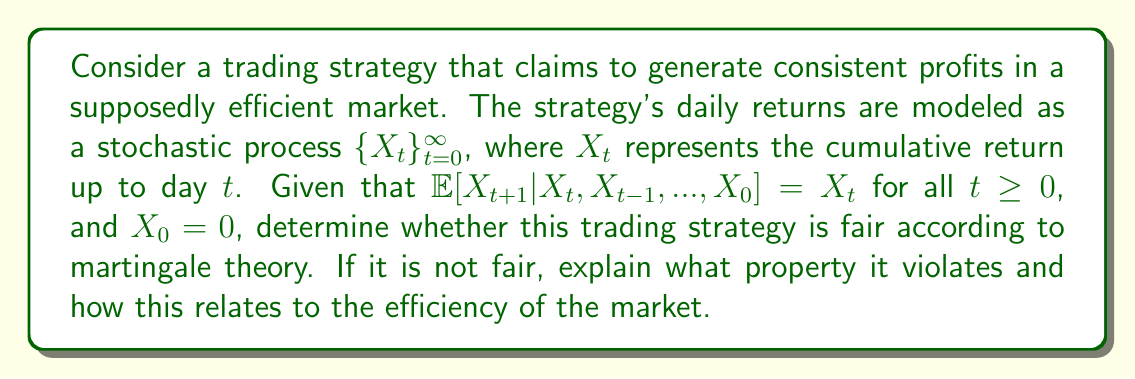What is the answer to this math problem? To determine whether the trading strategy is fair according to martingale theory, we need to analyze the properties of the stochastic process $\{X_t\}_{t=0}^{\infty}$.

Step 1: Identify the martingale property.
A stochastic process $\{X_t\}_{t=0}^{\infty}$ is a martingale if it satisfies the following conditions:
1. $\mathbb{E}[|X_t|] < \infty$ for all $t \geq 0$
2. $\mathbb{E}[X_{t+1}|X_t, X_{t-1}, ..., X_0] = X_t$ for all $t \geq 0$

Step 2: Analyze the given information.
We are given that $\mathbb{E}[X_{t+1}|X_t, X_{t-1}, ..., X_0] = X_t$ for all $t \geq 0$, which satisfies the second condition of a martingale. We can assume that the first condition is also met, as it's a reasonable assumption for financial returns.

Step 3: Determine if the process is a martingale.
Based on the given information, the stochastic process $\{X_t\}_{t=0}^{\infty}$ satisfies the martingale property.

Step 4: Interpret the martingale property in the context of trading strategies.
A martingale represents a fair game or, in this case, a fair trading strategy. The expected future value of the process, given all past information, is equal to the current value. This implies that there is no systematic way to profit from the strategy based on past information.

Step 5: Relate to market efficiency.
In an efficient market, it should not be possible to consistently generate excess returns using only past information. The martingale property of this trading strategy aligns with the concept of market efficiency, as it suggests that future returns cannot be predicted based on past returns.

Step 6: Conclusion.
The trading strategy is fair according to martingale theory. It does not violate any properties of a martingale, and its behavior is consistent with what we would expect in an efficient market.
Answer: The trading strategy is fair, as it satisfies the martingale property. 